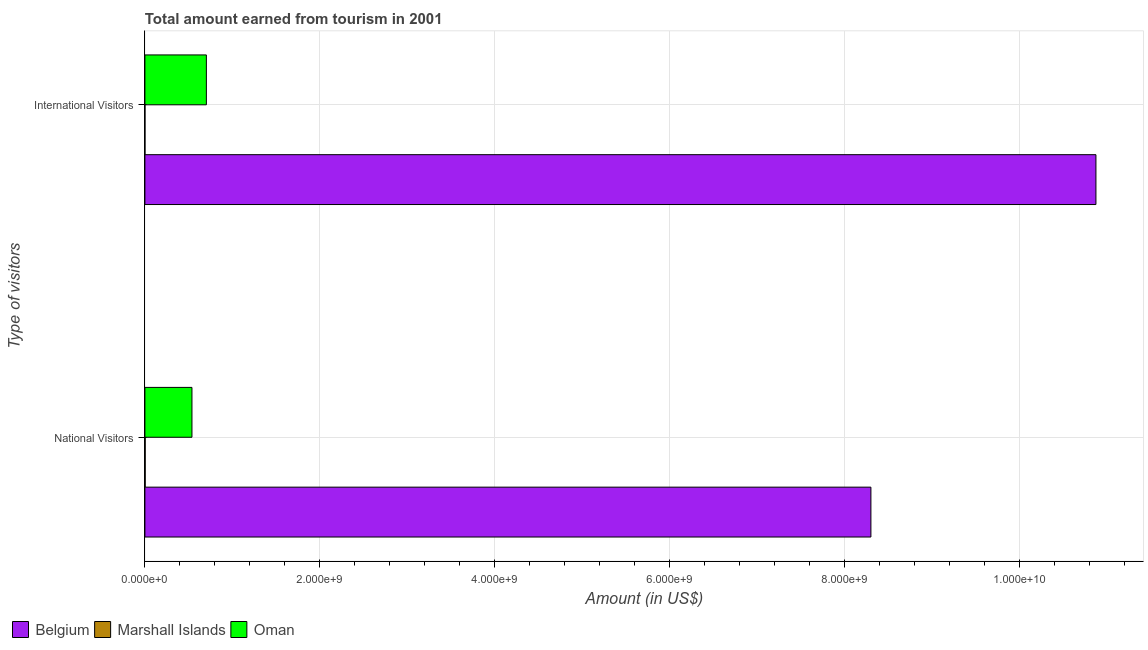How many different coloured bars are there?
Keep it short and to the point. 3. How many groups of bars are there?
Provide a short and direct response. 2. Are the number of bars per tick equal to the number of legend labels?
Offer a terse response. Yes. Are the number of bars on each tick of the Y-axis equal?
Give a very brief answer. Yes. How many bars are there on the 2nd tick from the top?
Offer a terse response. 3. How many bars are there on the 2nd tick from the bottom?
Offer a terse response. 3. What is the label of the 2nd group of bars from the top?
Provide a succinct answer. National Visitors. What is the amount earned from national visitors in Belgium?
Ensure brevity in your answer.  8.30e+09. Across all countries, what is the maximum amount earned from international visitors?
Ensure brevity in your answer.  1.09e+1. Across all countries, what is the minimum amount earned from international visitors?
Keep it short and to the point. 3.00e+05. In which country was the amount earned from international visitors maximum?
Keep it short and to the point. Belgium. In which country was the amount earned from national visitors minimum?
Offer a very short reply. Marshall Islands. What is the total amount earned from international visitors in the graph?
Give a very brief answer. 1.16e+1. What is the difference between the amount earned from international visitors in Oman and that in Belgium?
Keep it short and to the point. -1.02e+1. What is the difference between the amount earned from national visitors in Oman and the amount earned from international visitors in Marshall Islands?
Provide a succinct answer. 5.38e+08. What is the average amount earned from international visitors per country?
Your response must be concise. 3.86e+09. What is the difference between the amount earned from international visitors and amount earned from national visitors in Belgium?
Keep it short and to the point. 2.57e+09. What is the ratio of the amount earned from national visitors in Belgium to that in Oman?
Your response must be concise. 15.43. In how many countries, is the amount earned from international visitors greater than the average amount earned from international visitors taken over all countries?
Your response must be concise. 1. What does the 1st bar from the top in National Visitors represents?
Make the answer very short. Oman. What does the 3rd bar from the bottom in International Visitors represents?
Provide a succinct answer. Oman. How many bars are there?
Provide a succinct answer. 6. How many countries are there in the graph?
Keep it short and to the point. 3. Are the values on the major ticks of X-axis written in scientific E-notation?
Give a very brief answer. Yes. Where does the legend appear in the graph?
Your answer should be compact. Bottom left. How many legend labels are there?
Offer a terse response. 3. What is the title of the graph?
Your answer should be compact. Total amount earned from tourism in 2001. What is the label or title of the X-axis?
Offer a terse response. Amount (in US$). What is the label or title of the Y-axis?
Ensure brevity in your answer.  Type of visitors. What is the Amount (in US$) of Belgium in National Visitors?
Your answer should be compact. 8.30e+09. What is the Amount (in US$) of Marshall Islands in National Visitors?
Give a very brief answer. 3.10e+06. What is the Amount (in US$) of Oman in National Visitors?
Provide a succinct answer. 5.38e+08. What is the Amount (in US$) in Belgium in International Visitors?
Give a very brief answer. 1.09e+1. What is the Amount (in US$) in Marshall Islands in International Visitors?
Ensure brevity in your answer.  3.00e+05. What is the Amount (in US$) in Oman in International Visitors?
Your answer should be very brief. 7.03e+08. Across all Type of visitors, what is the maximum Amount (in US$) of Belgium?
Your answer should be compact. 1.09e+1. Across all Type of visitors, what is the maximum Amount (in US$) in Marshall Islands?
Provide a short and direct response. 3.10e+06. Across all Type of visitors, what is the maximum Amount (in US$) of Oman?
Keep it short and to the point. 7.03e+08. Across all Type of visitors, what is the minimum Amount (in US$) of Belgium?
Your answer should be compact. 8.30e+09. Across all Type of visitors, what is the minimum Amount (in US$) of Marshall Islands?
Your answer should be very brief. 3.00e+05. Across all Type of visitors, what is the minimum Amount (in US$) in Oman?
Provide a short and direct response. 5.38e+08. What is the total Amount (in US$) in Belgium in the graph?
Make the answer very short. 1.92e+1. What is the total Amount (in US$) of Marshall Islands in the graph?
Ensure brevity in your answer.  3.40e+06. What is the total Amount (in US$) in Oman in the graph?
Provide a succinct answer. 1.24e+09. What is the difference between the Amount (in US$) of Belgium in National Visitors and that in International Visitors?
Make the answer very short. -2.57e+09. What is the difference between the Amount (in US$) in Marshall Islands in National Visitors and that in International Visitors?
Your answer should be compact. 2.80e+06. What is the difference between the Amount (in US$) of Oman in National Visitors and that in International Visitors?
Your answer should be very brief. -1.65e+08. What is the difference between the Amount (in US$) of Belgium in National Visitors and the Amount (in US$) of Marshall Islands in International Visitors?
Give a very brief answer. 8.30e+09. What is the difference between the Amount (in US$) of Belgium in National Visitors and the Amount (in US$) of Oman in International Visitors?
Your answer should be compact. 7.60e+09. What is the difference between the Amount (in US$) in Marshall Islands in National Visitors and the Amount (in US$) in Oman in International Visitors?
Provide a succinct answer. -7.00e+08. What is the average Amount (in US$) in Belgium per Type of visitors?
Offer a terse response. 9.59e+09. What is the average Amount (in US$) of Marshall Islands per Type of visitors?
Your answer should be compact. 1.70e+06. What is the average Amount (in US$) in Oman per Type of visitors?
Your answer should be very brief. 6.20e+08. What is the difference between the Amount (in US$) of Belgium and Amount (in US$) of Marshall Islands in National Visitors?
Keep it short and to the point. 8.30e+09. What is the difference between the Amount (in US$) of Belgium and Amount (in US$) of Oman in National Visitors?
Offer a terse response. 7.77e+09. What is the difference between the Amount (in US$) in Marshall Islands and Amount (in US$) in Oman in National Visitors?
Provide a succinct answer. -5.35e+08. What is the difference between the Amount (in US$) of Belgium and Amount (in US$) of Marshall Islands in International Visitors?
Make the answer very short. 1.09e+1. What is the difference between the Amount (in US$) of Belgium and Amount (in US$) of Oman in International Visitors?
Offer a very short reply. 1.02e+1. What is the difference between the Amount (in US$) in Marshall Islands and Amount (in US$) in Oman in International Visitors?
Offer a terse response. -7.03e+08. What is the ratio of the Amount (in US$) in Belgium in National Visitors to that in International Visitors?
Your answer should be compact. 0.76. What is the ratio of the Amount (in US$) of Marshall Islands in National Visitors to that in International Visitors?
Keep it short and to the point. 10.33. What is the ratio of the Amount (in US$) of Oman in National Visitors to that in International Visitors?
Make the answer very short. 0.77. What is the difference between the highest and the second highest Amount (in US$) of Belgium?
Your answer should be compact. 2.57e+09. What is the difference between the highest and the second highest Amount (in US$) of Marshall Islands?
Offer a very short reply. 2.80e+06. What is the difference between the highest and the second highest Amount (in US$) in Oman?
Ensure brevity in your answer.  1.65e+08. What is the difference between the highest and the lowest Amount (in US$) of Belgium?
Make the answer very short. 2.57e+09. What is the difference between the highest and the lowest Amount (in US$) of Marshall Islands?
Provide a succinct answer. 2.80e+06. What is the difference between the highest and the lowest Amount (in US$) of Oman?
Your answer should be compact. 1.65e+08. 